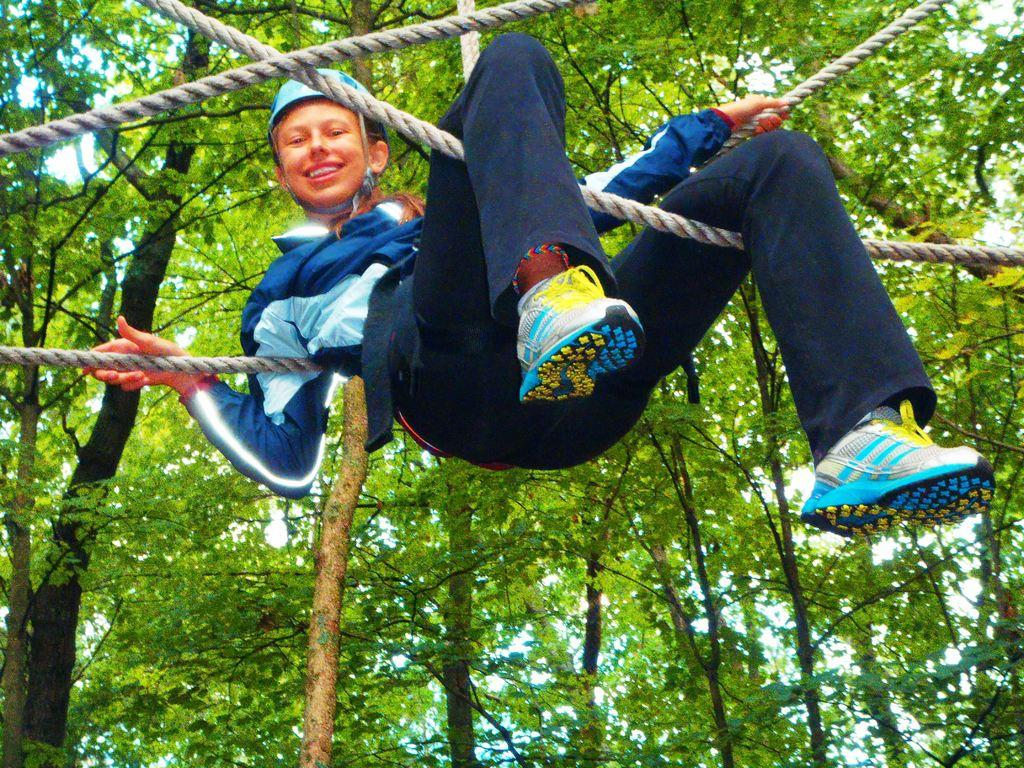Who or what is in the image? There is a person in the image. What is the person doing in the image? The person is sitting on ropes. Where are the ropes hanging from? The ropes are hanging from trees. What can be seen in the background of the image? There is sky visible in the background of the image. How does the person in the image demonstrate their muscle strength? The image does not show the person demonstrating their muscle strength, as they are simply sitting on ropes. Can you describe the flight path of the birds in the image? There are no birds present in the image, so it is not possible to describe their flight path. 